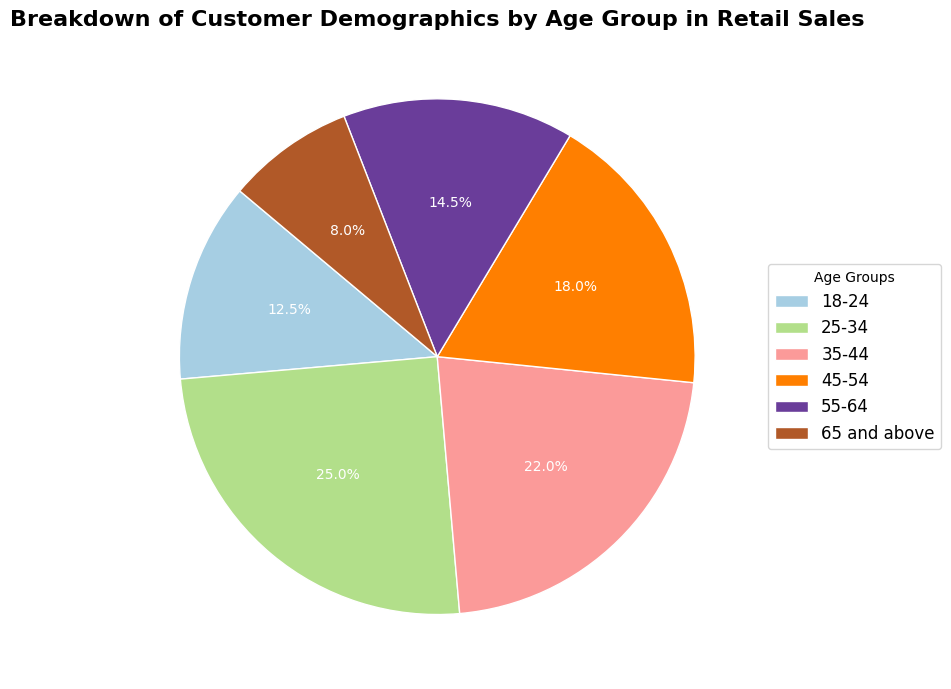What percentage of customers are aged between 25 and 34? Locate the '25-34' age group in the pie chart and note the percentage provided. The chart shows that this group makes up 25.0% of the total customers.
Answer: 25.0% Which age group has the smallest percentage of customers? Identify the smallest wedge in the pie chart and refer to its label. The '65 and above' age group has the smallest slice, corresponding to 8.0%.
Answer: 65 and above What percentage of customers are aged 45 and above? Sum the percentages of the age groups '45-54', '55-64', and '65 and above'. (18.0% + 14.5% + 8.0% = 40.5%)
Answer: 40.5% Which age group has a higher percentage of customers, 35-44 or 45-54? Compare the percentages of the '35-44' and '45-54' age groups in the pie chart. The '35-44' age group has 22.0%, while the '45-54' age group has 18.0%.
Answer: 35-44 How much larger is the percentage of the 25-34 age group compared to the 65 and above group? Subtract the percentage value of the '65 and above' group from the '25-34' group. (25.0% - 8.0% = 17.0%)
Answer: 17.0% What is the total percentage of customers aged between 18 and 44? Sum the percentages of the age groups '18-24', '25-34', and '35-44'. (12.5% + 25.0% + 22.0% = 59.5%)
Answer: 59.5% Which age group has the second-largest percentage of customers? Identify the wedge with the second-largest slice in the pie chart and refer to its label. The '35-44' age group has the second-largest percentage at 22.0%.
Answer: 35-44 Which age group has a smaller percentage of customers, 18-24 or 55-64? Compare the percentages of the '18-24' and '55-64' age groups in the pie chart. The '18-24' age group has 12.5%, while the '55-64' age group has 14.5%.
Answer: 18-24 What is the combined percentage of the two largest age groups? Identify the two age groups with the largest wedges and sum their percentages. The '25-34' age group has 25.0% and the '35-44' age group has 22.0%. (25.0% + 22.0% = 47.0%)
Answer: 47.0% Which age group's wedge has a color closest to the center of the spectrum? Visually inspect the wedges in the pie chart and judge which wedge has a color in the middle of the spectrum. Use the standard color spectrum as a reference if necessary.
Answer: 45-54 